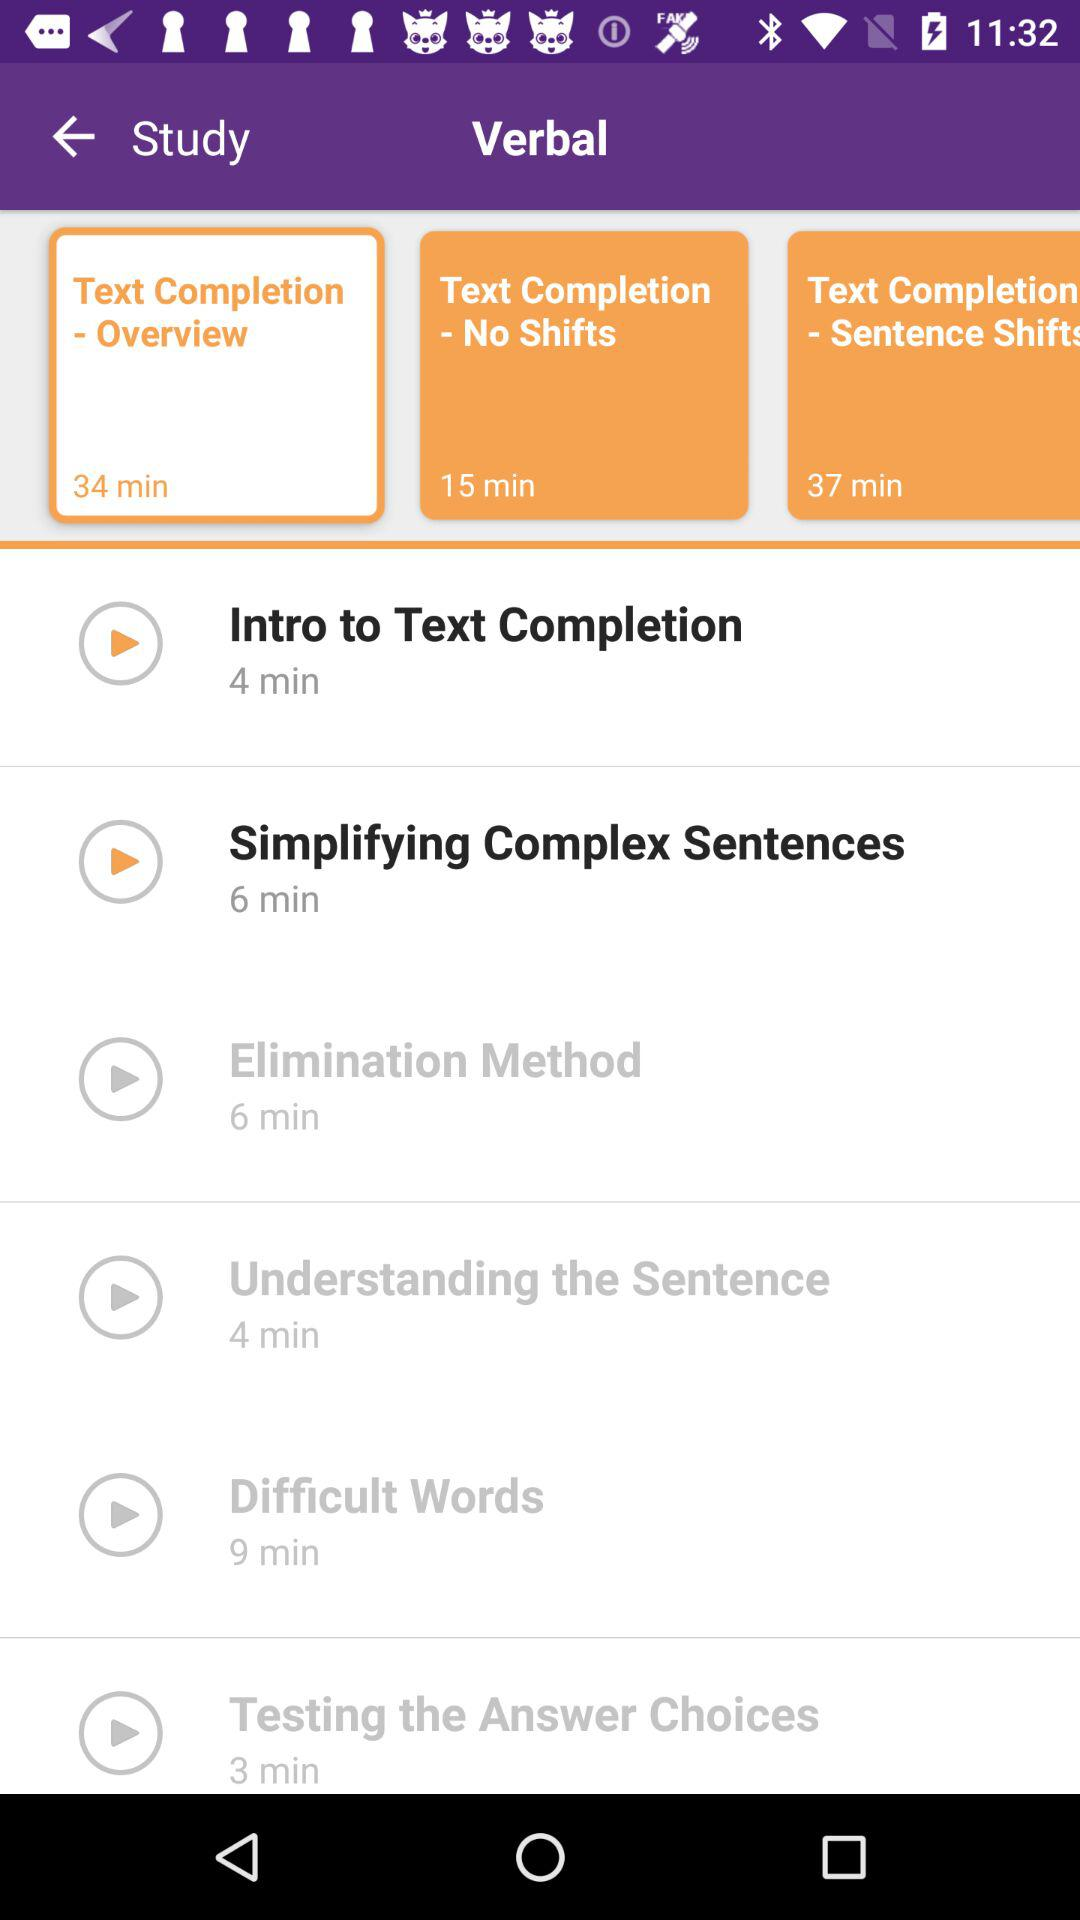What is the duration of the "Intro to Text Completion" video? The duration of the video is 4 minutes. 